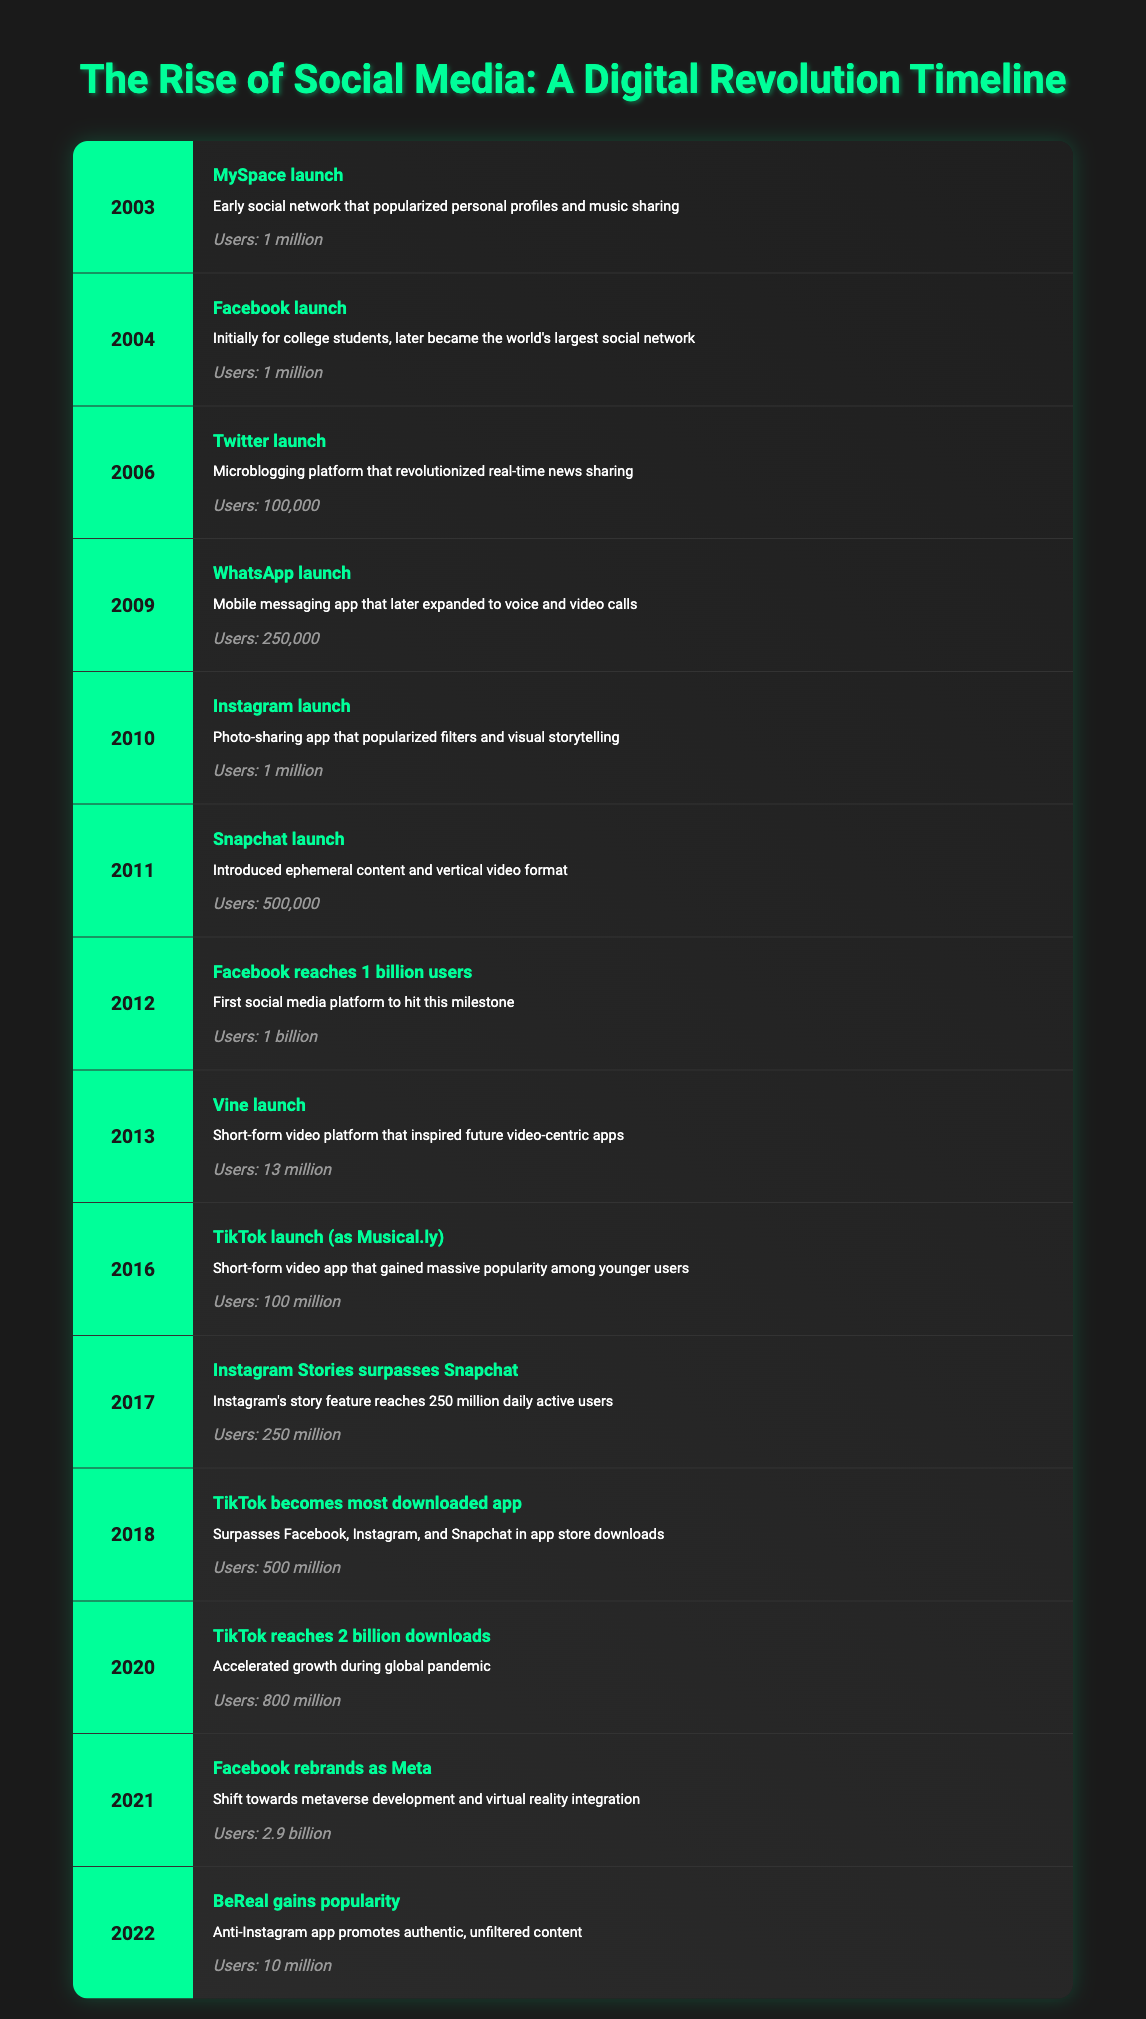What year did Facebook launch? Facebook launched in 2004, as indicated in the table under the events listed.
Answer: 2004 How many users did WhatsApp have at its launch? The table states that WhatsApp launched in 2009 with 250,000 users.
Answer: 250,000 Which social media platform reached 1 billion users in 2012? According to the table, Facebook was the platform that reached 1 billion users in 2012.
Answer: Facebook What is the total number of users for TikTok in the years 2016, 2018, and 2020? In 2016, TikTok had 100 million users, in 2018 it had 500 million users, and in 2020 it reached 800 million users. Summing these gives: 100 million + 500 million + 800 million = 1.4 billion.
Answer: 1.4 billion Did Instagram launch before or after Snapchat? The table shows Instagram launched in 2010 and Snapchat in 2011, so Instagram launched before Snapchat.
Answer: Yes How was the user count for Vine at launch compared to Snapchat's user count at launch? Vine launched in 2013 with 13 million users, while Snapchat launched in 2011 with 500,000 users. Comparing these, Vine had significantly more users at launch than Snapchat.
Answer: Vine had more users What is the median user count of all platforms listed in the table? First, we list the user counts: 1 million, 1 million, 100,000, 250,000, 1 million, 500,000, 1 billion, 13 million, 100 million, 250 million, 500 million, 800 million, 2.9 billion, and 10 million. Putting them in order gives a sequence of 100,000, 250,000, 500,000, 1 million, 1 million, 1 million, 10 million, 13 million, 100 million, 250 million, 500 million, 800 million, 1 billion, 2.9 billion. Since there are 14 platforms, the median will be the average of the 7th and 8th values: (10 million + 13 million) / 2 = 11.5 million.
Answer: 11.5 million Which platform had the fastest growth in user base between its launch and the end of 2020? Comparing the user growth from launch to the end of 2020: TikTok had 100 million users in 2016 and 800 million by 2020, indicating rapid growth. No other platform shows such growth in that timeframe.
Answer: TikTok Did any platform outpace Facebook's user growth by the end of 2021? By the end of 2021, Facebook had 2.9 billion users. The table shows no other platform had outpaced this number, with TikTok at 800 million and Instagram at a lesser count.
Answer: No 